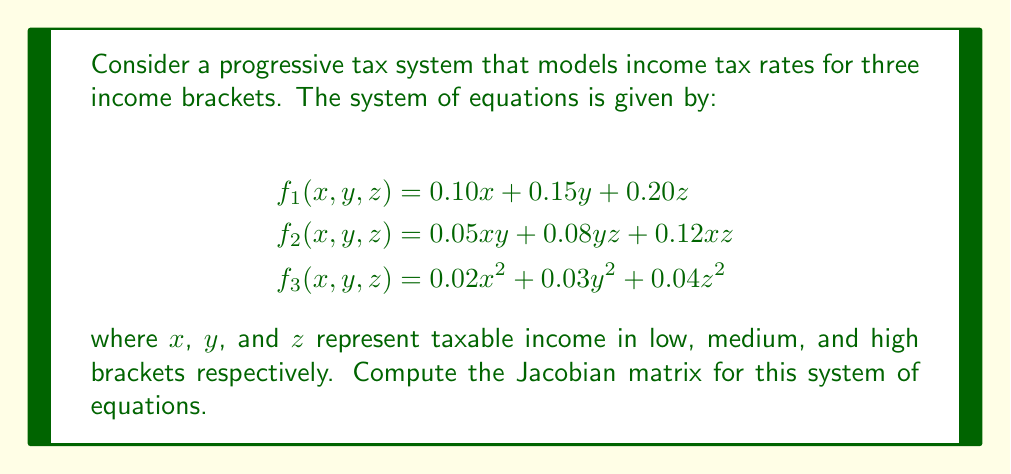Solve this math problem. To compute the Jacobian matrix, we need to find the partial derivatives of each function with respect to each variable. The Jacobian matrix is a 3x3 matrix in this case, as we have three functions and three variables.

Step 1: Calculate partial derivatives for $f_1(x, y, z)$
$$\frac{\partial f_1}{\partial x} = 0.10, \quad \frac{\partial f_1}{\partial y} = 0.15, \quad \frac{\partial f_1}{\partial z} = 0.20$$

Step 2: Calculate partial derivatives for $f_2(x, y, z)$
$$\frac{\partial f_2}{\partial x} = 0.05y + 0.12z, \quad \frac{\partial f_2}{\partial y} = 0.05x + 0.08z, \quad \frac{\partial f_2}{\partial z} = 0.08y + 0.12x$$

Step 3: Calculate partial derivatives for $f_3(x, y, z)$
$$\frac{\partial f_3}{\partial x} = 0.04x, \quad \frac{\partial f_3}{\partial y} = 0.06y, \quad \frac{\partial f_3}{\partial z} = 0.08z$$

Step 4: Construct the Jacobian matrix using the calculated partial derivatives

$$J = \begin{bmatrix}
\frac{\partial f_1}{\partial x} & \frac{\partial f_1}{\partial y} & \frac{\partial f_1}{\partial z} \\
\frac{\partial f_2}{\partial x} & \frac{\partial f_2}{\partial y} & \frac{\partial f_2}{\partial z} \\
\frac{\partial f_3}{\partial x} & \frac{\partial f_3}{\partial y} & \frac{\partial f_3}{\partial z}
\end{bmatrix}$$

Substituting the calculated partial derivatives:

$$J = \begin{bmatrix}
0.10 & 0.15 & 0.20 \\
0.05y + 0.12z & 0.05x + 0.08z & 0.08y + 0.12x \\
0.04x & 0.06y & 0.08z
\end{bmatrix}$$

This Jacobian matrix represents the rates of change in tax calculations across different income brackets, which is crucial for understanding the impact of progressive tax policies supported by the DFL party.
Answer: $$J = \begin{bmatrix}
0.10 & 0.15 & 0.20 \\
0.05y + 0.12z & 0.05x + 0.08z & 0.08y + 0.12x \\
0.04x & 0.06y & 0.08z
\end{bmatrix}$$ 